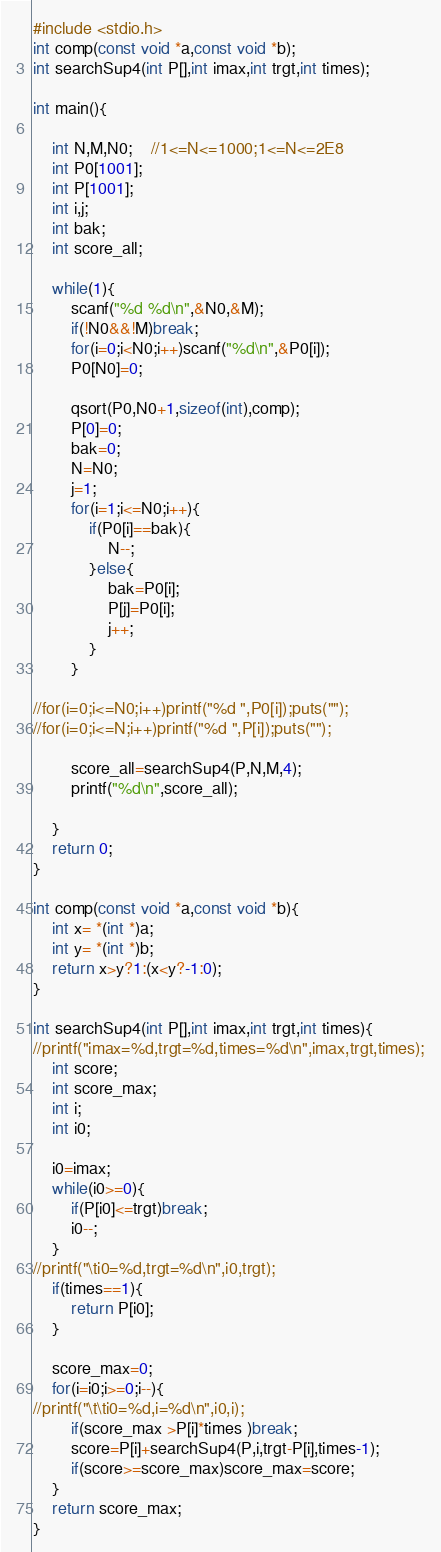Convert code to text. <code><loc_0><loc_0><loc_500><loc_500><_C_>#include <stdio.h>
int comp(const void *a,const void *b);
int searchSup4(int P[],int imax,int trgt,int times);

int main(){

	int N,M,N0;	//1<=N<=1000;1<=N<=2E8
	int P0[1001];
	int P[1001];
	int i,j;
	int bak;
	int score_all;
	
	while(1){
		scanf("%d %d\n",&N0,&M);
		if(!N0&&!M)break;
		for(i=0;i<N0;i++)scanf("%d\n",&P0[i]);
		P0[N0]=0;
		
		qsort(P0,N0+1,sizeof(int),comp);
		P[0]=0;
		bak=0;
		N=N0;
		j=1;
		for(i=1;i<=N0;i++){
			if(P0[i]==bak){
				N--;
			}else{
				bak=P0[i];
				P[j]=P0[i];
				j++;
			}
		}
		
//for(i=0;i<=N0;i++)printf("%d ",P0[i]);puts("");
//for(i=0;i<=N;i++)printf("%d ",P[i]);puts("");

		score_all=searchSup4(P,N,M,4);
		printf("%d\n",score_all);
		
	}
	return 0;
}

int comp(const void *a,const void *b){
	int x= *(int *)a;
	int y= *(int *)b;
	return x>y?1:(x<y?-1:0);
}

int searchSup4(int P[],int imax,int trgt,int times){
//printf("imax=%d,trgt=%d,times=%d\n",imax,trgt,times);
	int score;
	int score_max;
	int i;
	int i0;
	
	i0=imax;
	while(i0>=0){
		if(P[i0]<=trgt)break;
		i0--;
	}
//printf("\ti0=%d,trgt=%d\n",i0,trgt);
	if(times==1){
		return P[i0];
	}
	
	score_max=0;
	for(i=i0;i>=0;i--){
//printf("\t\ti0=%d,i=%d\n",i0,i);
		if(score_max >P[i]*times )break;
		score=P[i]+searchSup4(P,i,trgt-P[i],times-1);
		if(score>=score_max)score_max=score;
	}
	return score_max;
}</code> 